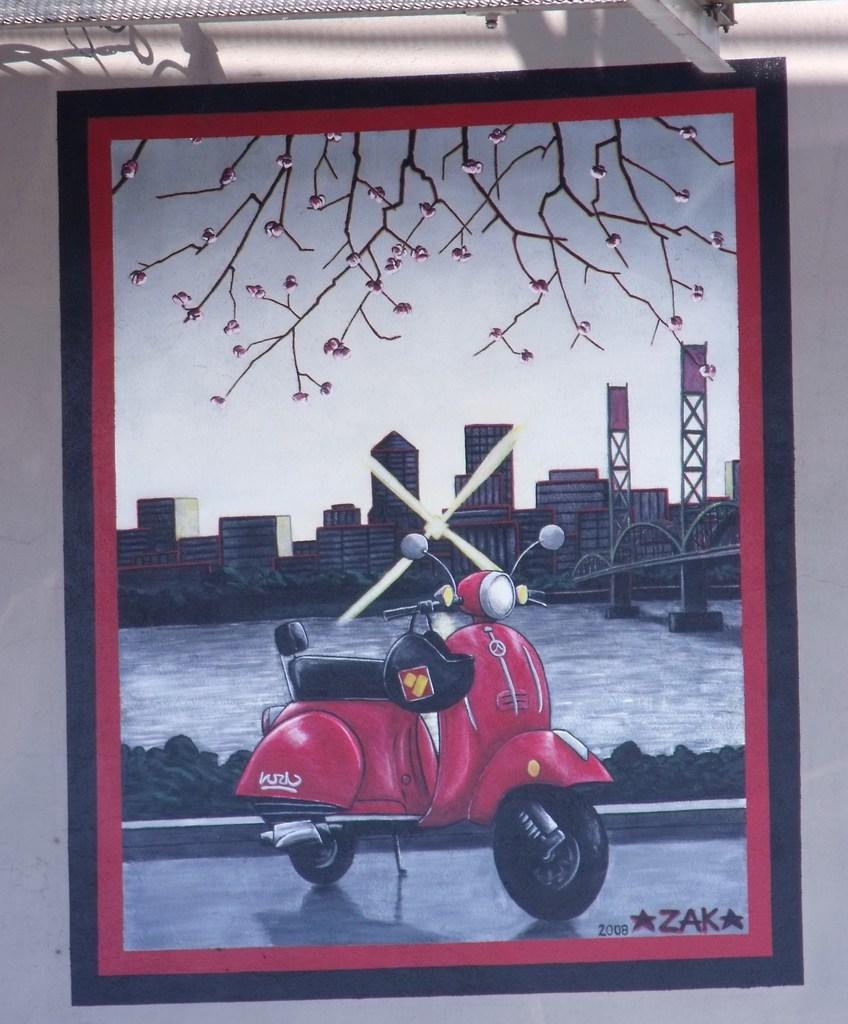What is hanging on the wall in the image? There is a photo frame on the wall. What is depicted in the photo frame? The photo frame contains an image of a motorcycle. What elements are present in the image within the photo frame? The image includes buildings, water, a bridge, a tree, and the sky. Is there any text visible in the image? Yes, there is text visible in the image. What type of turkey can be seen walking through the gate in the image? There is no turkey or gate present in the image; it features a motorcycle and various landscape elements. What question is being asked in the image? There is no question visible in the image; it contains an image of a motorcycle and text. 